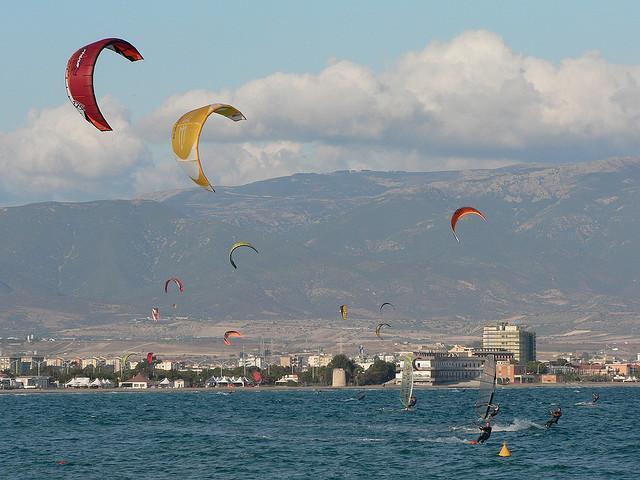How many kites are in the picture?
Give a very brief answer. 2. How many burned sousages are on the pizza on wright?
Give a very brief answer. 0. 